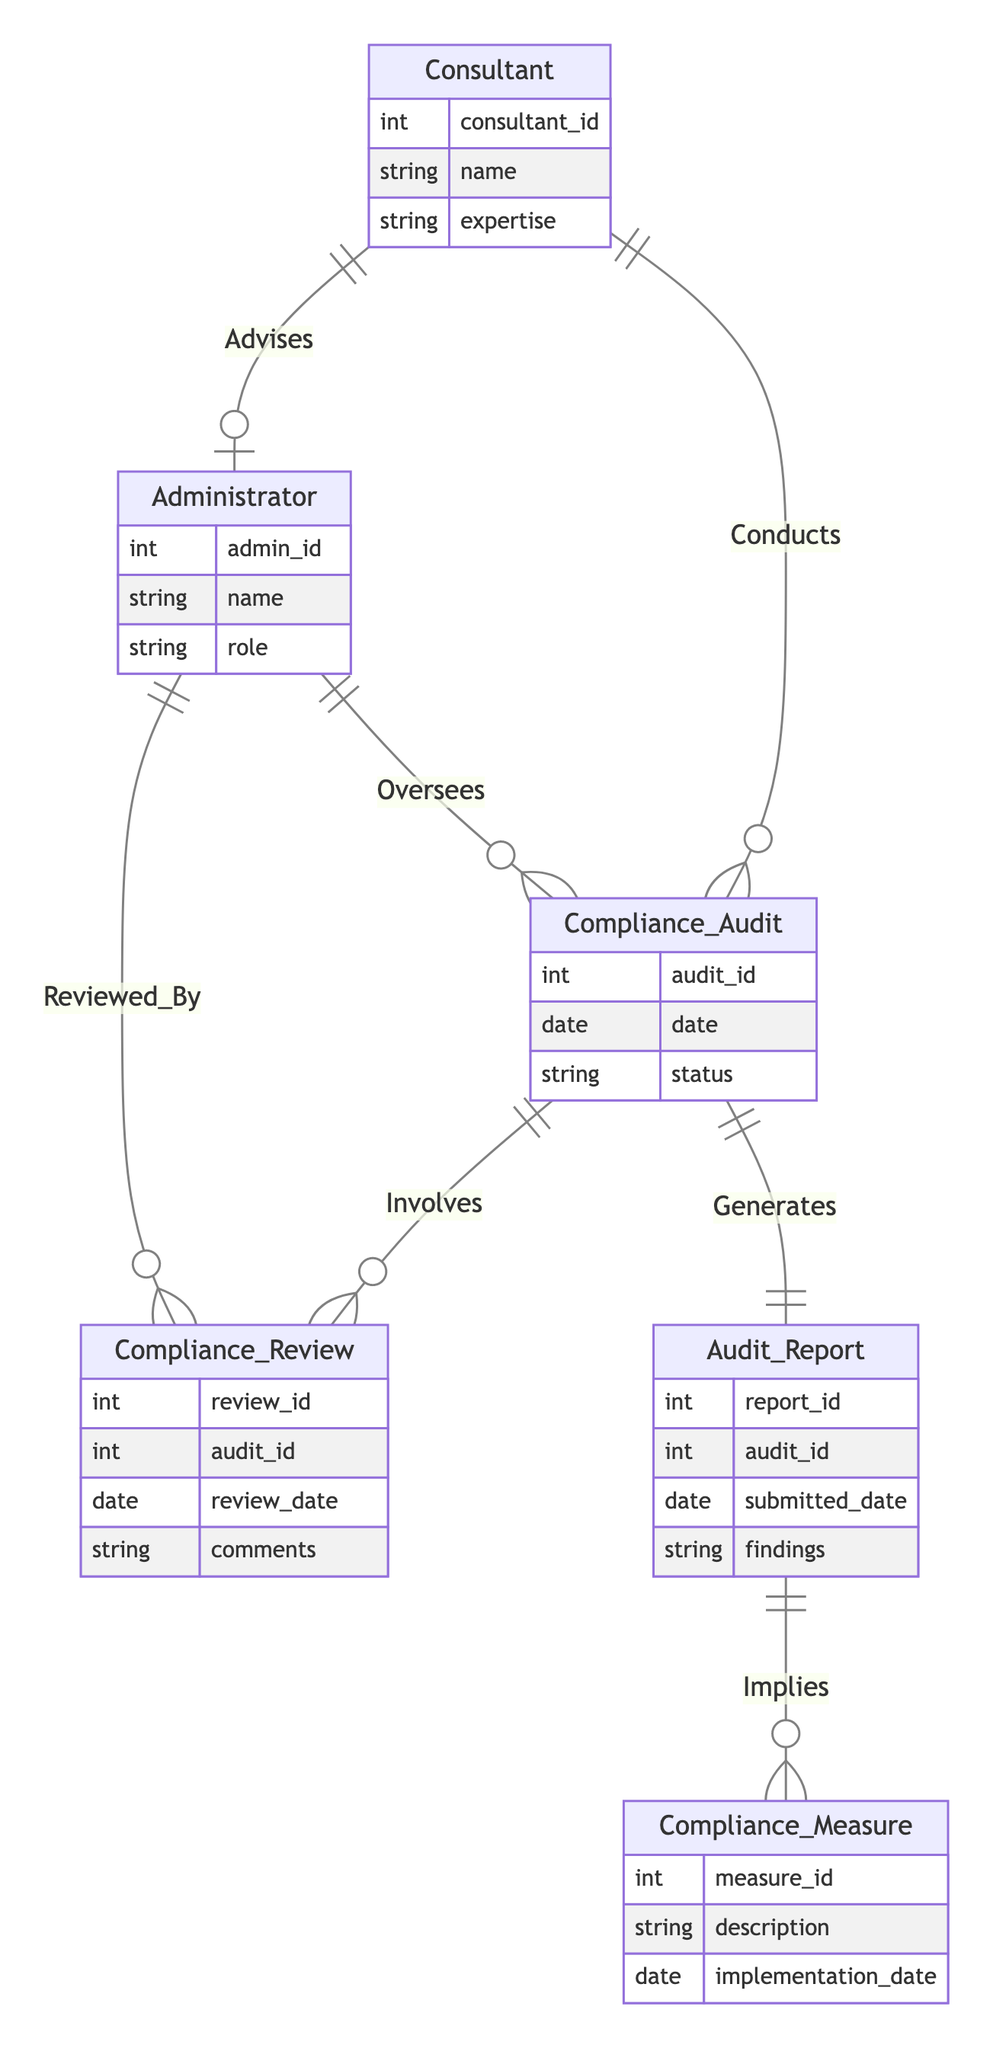What is the primary relationship between Administrator and Compliance Audit? The diagram shows that the Administrator "Oversees" the Compliance Audit. This indicates a direct supervisory relationship where the Administrator is responsible for the Compliance Audit process.
Answer: Oversees How many attributes does the Compliance_Audit entity have? The Compliance_Audit entity includes three attributes: audit_id, date, and status. This is based on the attribute listing for that entity in the diagram.
Answer: 3 Which entity has the attribute "expertise"? The attribute "expertise" belongs to the Consultant entity as indicated in the attributes section of that entity in the diagram.
Answer: Consultant What is the relationship called that links Compliance Audit and Audit Report? The relationship between Compliance Audit and Audit Report is called "Generates." This signifies that a Compliance Audit produces or leads to the creation of an Audit Report.
Answer: Generates Who advises the Administrator? The Consultant advises the Administrator, as depicted by the relationship labeled "Advises" in the diagram between these two entities.
Answer: Consultant What entity is involved in a Compliance Audit? The Compliance_Review entity is involved in a Compliance Audit, as the diagram shows that a Compliance Audit "Involves" Compliance Review.
Answer: Compliance_Review What happens after an Audit Report is generated? After an Audit Report is generated, it "Implies" Compliance Measures, indicating that the findings of an Audit Report lead to specific compliance measures being identified or required.
Answer: Implies How many entities are there in total? There are six entities represented in the diagram: Administrator, Consultant, Compliance_Audit, Audit_Report, Compliance_Review, and Compliance_Measure. This total is counted directly from the entities listed in the diagram.
Answer: 6 What type of document is generated by the Compliance Audit? The document generated by the Compliance Audit is called an Audit Report. This is derived from the relationship defined as "Generates" connecting Compliance Audit to Audit Report.
Answer: Audit Report 